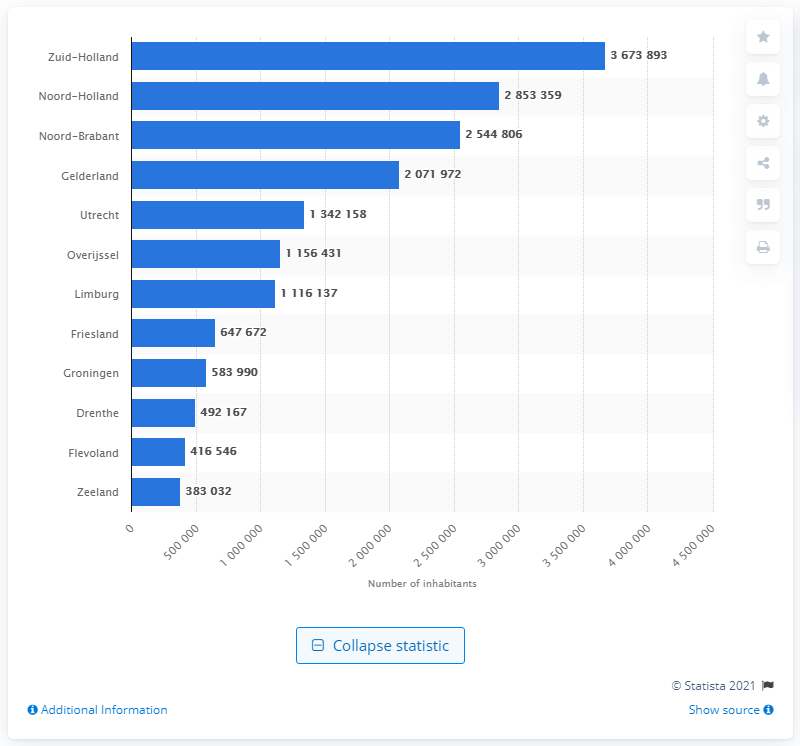Draw attention to some important aspects in this diagram. According to the latest statistics, in 2019, Zuid-Holland was the most populous province in the Netherlands. In 2019, an estimated 367,389 people lived in the province of Zuid-Holland. 